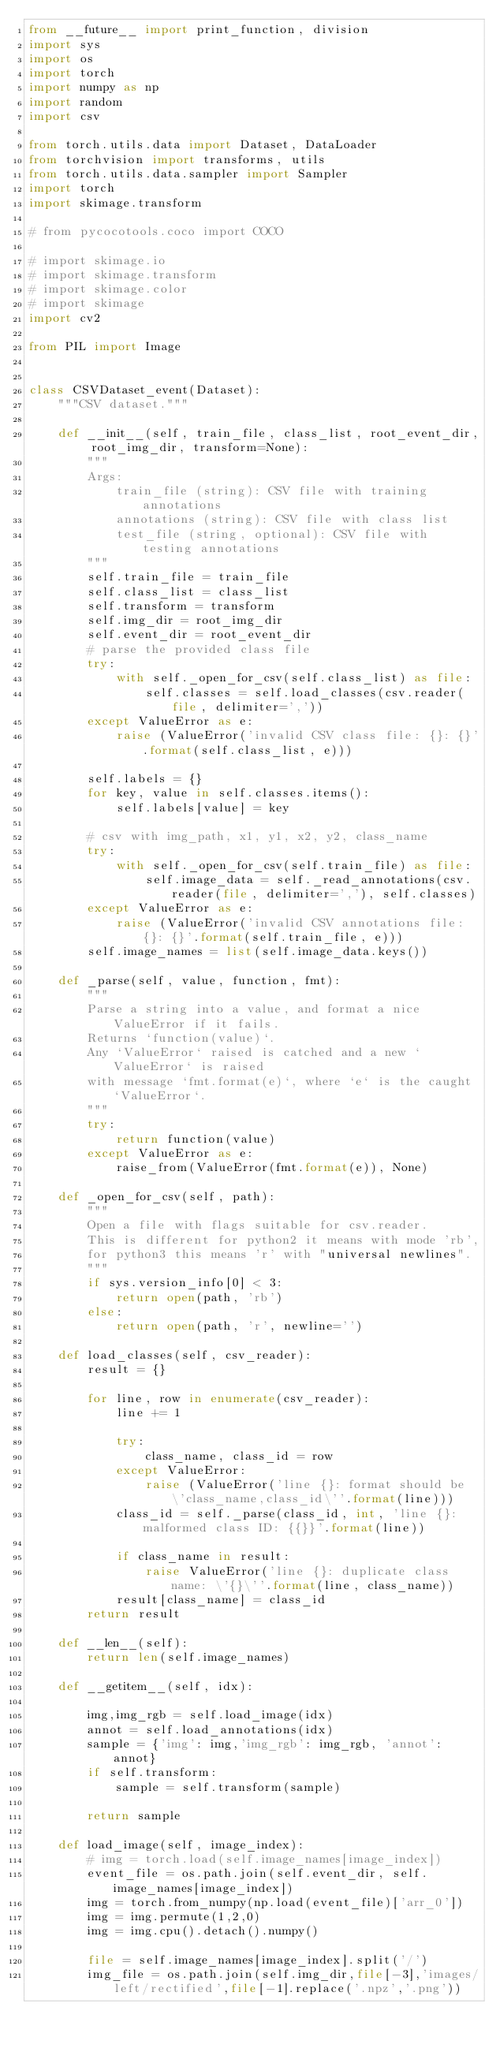<code> <loc_0><loc_0><loc_500><loc_500><_Python_>from __future__ import print_function, division
import sys
import os
import torch
import numpy as np
import random
import csv

from torch.utils.data import Dataset, DataLoader
from torchvision import transforms, utils
from torch.utils.data.sampler import Sampler
import torch
import skimage.transform

# from pycocotools.coco import COCO

# import skimage.io
# import skimage.transform
# import skimage.color
# import skimage
import cv2

from PIL import Image


class CSVDataset_event(Dataset):
    """CSV dataset."""

    def __init__(self, train_file, class_list, root_event_dir, root_img_dir, transform=None):
        """
        Args:
            train_file (string): CSV file with training annotations
            annotations (string): CSV file with class list
            test_file (string, optional): CSV file with testing annotations
        """
        self.train_file = train_file
        self.class_list = class_list
        self.transform = transform
        self.img_dir = root_img_dir
        self.event_dir = root_event_dir
        # parse the provided class file
        try:
            with self._open_for_csv(self.class_list) as file:
                self.classes = self.load_classes(csv.reader(file, delimiter=','))
        except ValueError as e:
            raise (ValueError('invalid CSV class file: {}: {}'.format(self.class_list, e)))

        self.labels = {}
        for key, value in self.classes.items():
            self.labels[value] = key

        # csv with img_path, x1, y1, x2, y2, class_name
        try:
            with self._open_for_csv(self.train_file) as file:
                self.image_data = self._read_annotations(csv.reader(file, delimiter=','), self.classes)
        except ValueError as e:
            raise (ValueError('invalid CSV annotations file: {}: {}'.format(self.train_file, e)))
        self.image_names = list(self.image_data.keys())

    def _parse(self, value, function, fmt):
        """
        Parse a string into a value, and format a nice ValueError if it fails.
        Returns `function(value)`.
        Any `ValueError` raised is catched and a new `ValueError` is raised
        with message `fmt.format(e)`, where `e` is the caught `ValueError`.
        """
        try:
            return function(value)
        except ValueError as e:
            raise_from(ValueError(fmt.format(e)), None)

    def _open_for_csv(self, path):
        """
        Open a file with flags suitable for csv.reader.
        This is different for python2 it means with mode 'rb',
        for python3 this means 'r' with "universal newlines".
        """
        if sys.version_info[0] < 3:
            return open(path, 'rb')
        else:
            return open(path, 'r', newline='')

    def load_classes(self, csv_reader):
        result = {}

        for line, row in enumerate(csv_reader):
            line += 1

            try:
                class_name, class_id = row
            except ValueError:
                raise (ValueError('line {}: format should be \'class_name,class_id\''.format(line)))
            class_id = self._parse(class_id, int, 'line {}: malformed class ID: {{}}'.format(line))

            if class_name in result:
                raise ValueError('line {}: duplicate class name: \'{}\''.format(line, class_name))
            result[class_name] = class_id
        return result

    def __len__(self):
        return len(self.image_names)

    def __getitem__(self, idx):

        img,img_rgb = self.load_image(idx)
        annot = self.load_annotations(idx)
        sample = {'img': img,'img_rgb': img_rgb, 'annot': annot}
        if self.transform:
            sample = self.transform(sample)

        return sample

    def load_image(self, image_index):
        # img = torch.load(self.image_names[image_index])
        event_file = os.path.join(self.event_dir, self.image_names[image_index])
        img = torch.from_numpy(np.load(event_file)['arr_0'])
        img = img.permute(1,2,0)
        img = img.cpu().detach().numpy()

        file = self.image_names[image_index].split('/')
        img_file = os.path.join(self.img_dir,file[-3],'images/left/rectified',file[-1].replace('.npz','.png'))</code> 